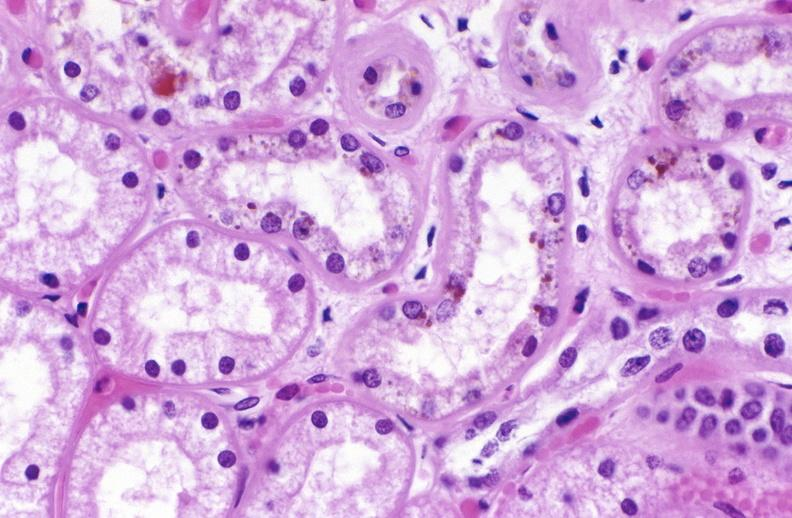does gangrene toe in infant show atn and bile pigment?
Answer the question using a single word or phrase. No 